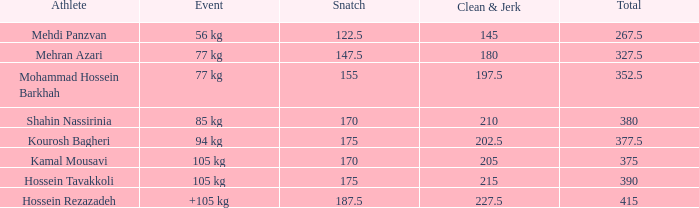What is the aggregate of participants who encountered a +105 kg incident and a clean & jerk lesser than 22 0.0. 